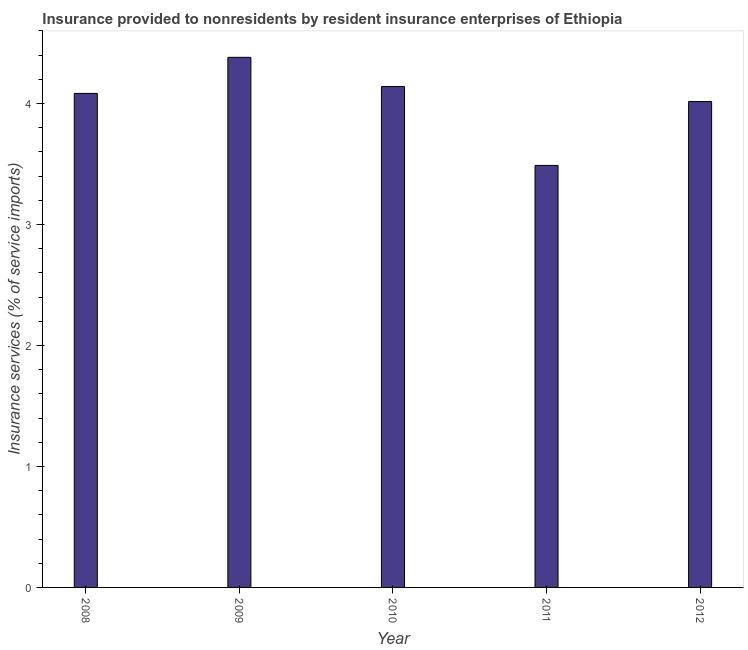Does the graph contain any zero values?
Make the answer very short. No. Does the graph contain grids?
Make the answer very short. No. What is the title of the graph?
Provide a succinct answer. Insurance provided to nonresidents by resident insurance enterprises of Ethiopia. What is the label or title of the Y-axis?
Provide a short and direct response. Insurance services (% of service imports). What is the insurance and financial services in 2011?
Provide a short and direct response. 3.49. Across all years, what is the maximum insurance and financial services?
Keep it short and to the point. 4.38. Across all years, what is the minimum insurance and financial services?
Offer a very short reply. 3.49. What is the sum of the insurance and financial services?
Provide a succinct answer. 20.11. What is the difference between the insurance and financial services in 2009 and 2011?
Offer a terse response. 0.89. What is the average insurance and financial services per year?
Provide a short and direct response. 4.02. What is the median insurance and financial services?
Keep it short and to the point. 4.08. Do a majority of the years between 2008 and 2009 (inclusive) have insurance and financial services greater than 4.4 %?
Offer a very short reply. No. What is the ratio of the insurance and financial services in 2010 to that in 2011?
Keep it short and to the point. 1.19. Is the insurance and financial services in 2009 less than that in 2010?
Your answer should be very brief. No. What is the difference between the highest and the second highest insurance and financial services?
Your answer should be compact. 0.24. What is the difference between the highest and the lowest insurance and financial services?
Offer a very short reply. 0.89. In how many years, is the insurance and financial services greater than the average insurance and financial services taken over all years?
Offer a very short reply. 3. How many years are there in the graph?
Provide a short and direct response. 5. Are the values on the major ticks of Y-axis written in scientific E-notation?
Offer a very short reply. No. What is the Insurance services (% of service imports) of 2008?
Ensure brevity in your answer.  4.08. What is the Insurance services (% of service imports) in 2009?
Your answer should be very brief. 4.38. What is the Insurance services (% of service imports) of 2010?
Your answer should be compact. 4.14. What is the Insurance services (% of service imports) of 2011?
Your response must be concise. 3.49. What is the Insurance services (% of service imports) in 2012?
Ensure brevity in your answer.  4.02. What is the difference between the Insurance services (% of service imports) in 2008 and 2009?
Offer a terse response. -0.3. What is the difference between the Insurance services (% of service imports) in 2008 and 2010?
Keep it short and to the point. -0.06. What is the difference between the Insurance services (% of service imports) in 2008 and 2011?
Your response must be concise. 0.6. What is the difference between the Insurance services (% of service imports) in 2008 and 2012?
Your answer should be very brief. 0.07. What is the difference between the Insurance services (% of service imports) in 2009 and 2010?
Make the answer very short. 0.24. What is the difference between the Insurance services (% of service imports) in 2009 and 2011?
Keep it short and to the point. 0.89. What is the difference between the Insurance services (% of service imports) in 2009 and 2012?
Make the answer very short. 0.37. What is the difference between the Insurance services (% of service imports) in 2010 and 2011?
Provide a succinct answer. 0.65. What is the difference between the Insurance services (% of service imports) in 2010 and 2012?
Your response must be concise. 0.12. What is the difference between the Insurance services (% of service imports) in 2011 and 2012?
Offer a very short reply. -0.53. What is the ratio of the Insurance services (% of service imports) in 2008 to that in 2009?
Offer a terse response. 0.93. What is the ratio of the Insurance services (% of service imports) in 2008 to that in 2011?
Make the answer very short. 1.17. What is the ratio of the Insurance services (% of service imports) in 2008 to that in 2012?
Provide a short and direct response. 1.02. What is the ratio of the Insurance services (% of service imports) in 2009 to that in 2010?
Make the answer very short. 1.06. What is the ratio of the Insurance services (% of service imports) in 2009 to that in 2011?
Ensure brevity in your answer.  1.26. What is the ratio of the Insurance services (% of service imports) in 2009 to that in 2012?
Make the answer very short. 1.09. What is the ratio of the Insurance services (% of service imports) in 2010 to that in 2011?
Ensure brevity in your answer.  1.19. What is the ratio of the Insurance services (% of service imports) in 2010 to that in 2012?
Your answer should be very brief. 1.03. What is the ratio of the Insurance services (% of service imports) in 2011 to that in 2012?
Your answer should be compact. 0.87. 